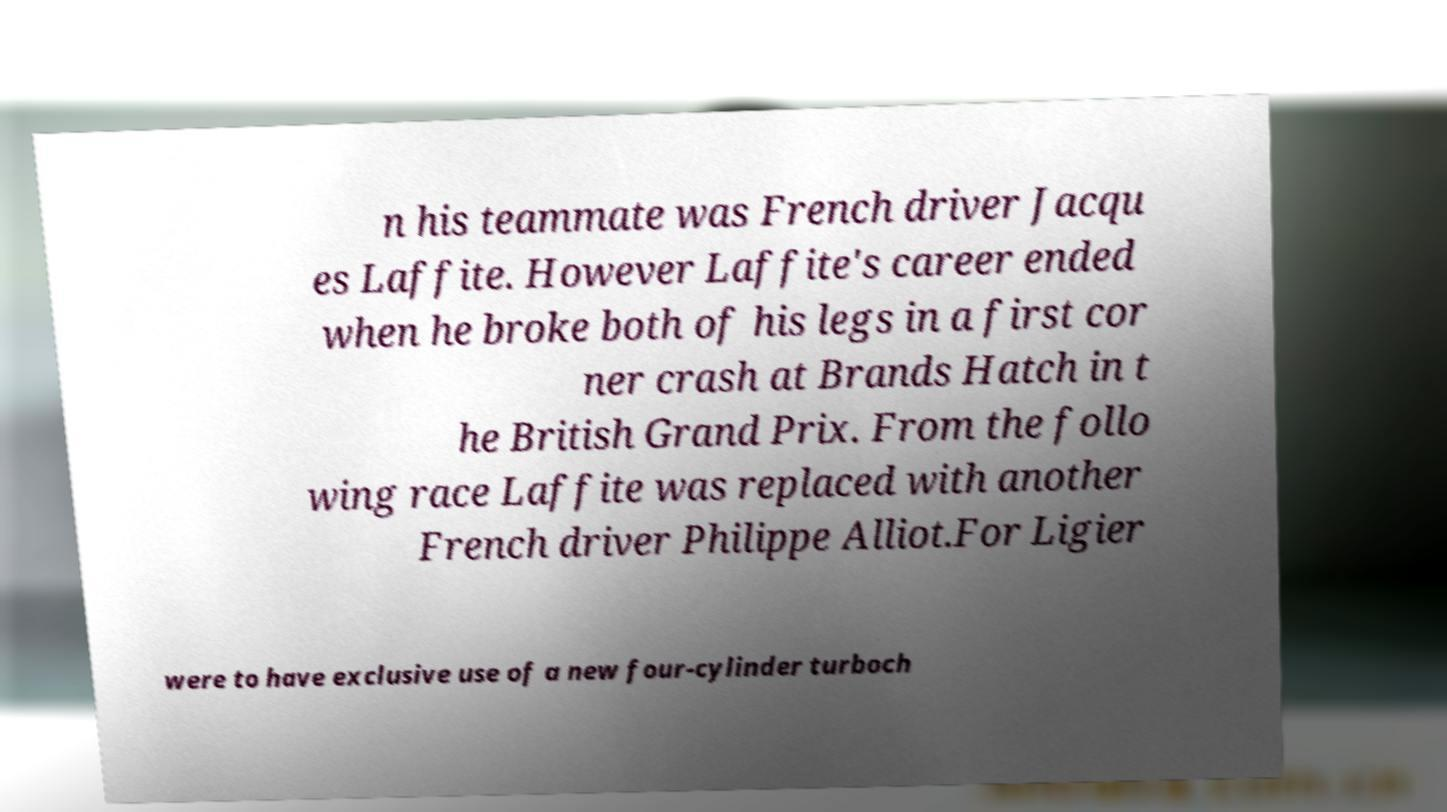I need the written content from this picture converted into text. Can you do that? n his teammate was French driver Jacqu es Laffite. However Laffite's career ended when he broke both of his legs in a first cor ner crash at Brands Hatch in t he British Grand Prix. From the follo wing race Laffite was replaced with another French driver Philippe Alliot.For Ligier were to have exclusive use of a new four-cylinder turboch 